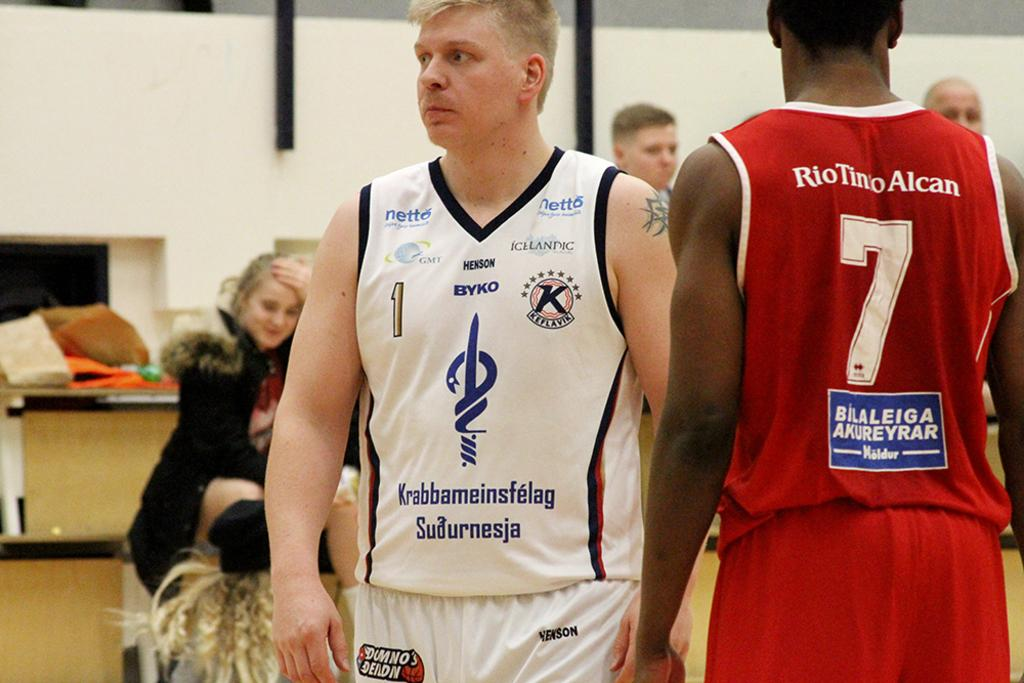Provide a one-sentence caption for the provided image. Sports athlete wearing a white uniform with Krabbameinsfelag Sudurnesja in blue lettering. 